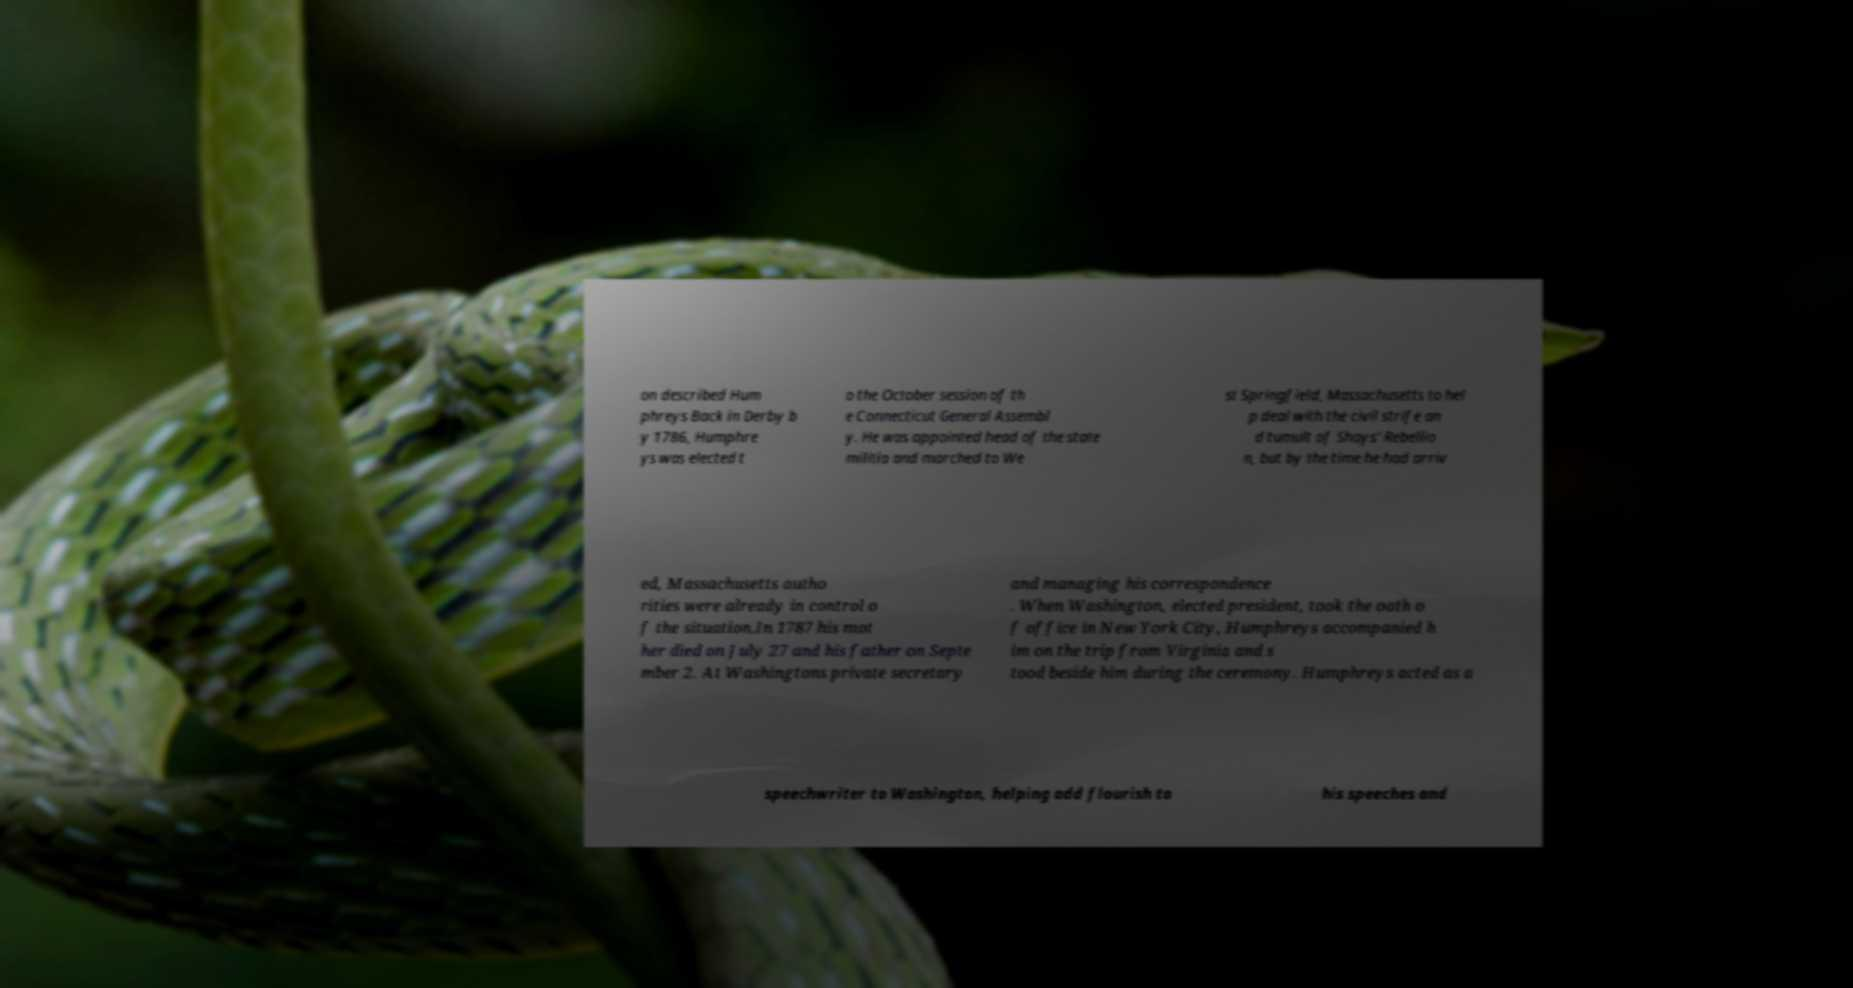Could you assist in decoding the text presented in this image and type it out clearly? on described Hum phreys Back in Derby b y 1786, Humphre ys was elected t o the October session of th e Connecticut General Assembl y. He was appointed head of the state militia and marched to We st Springfield, Massachusetts to hel p deal with the civil strife an d tumult of Shays' Rebellio n, but by the time he had arriv ed, Massachusetts autho rities were already in control o f the situation.In 1787 his mot her died on July 27 and his father on Septe mber 2. At Washingtons private secretary and managing his correspondence . When Washington, elected president, took the oath o f office in New York City, Humphreys accompanied h im on the trip from Virginia and s tood beside him during the ceremony. Humphreys acted as a speechwriter to Washington, helping add flourish to his speeches and 